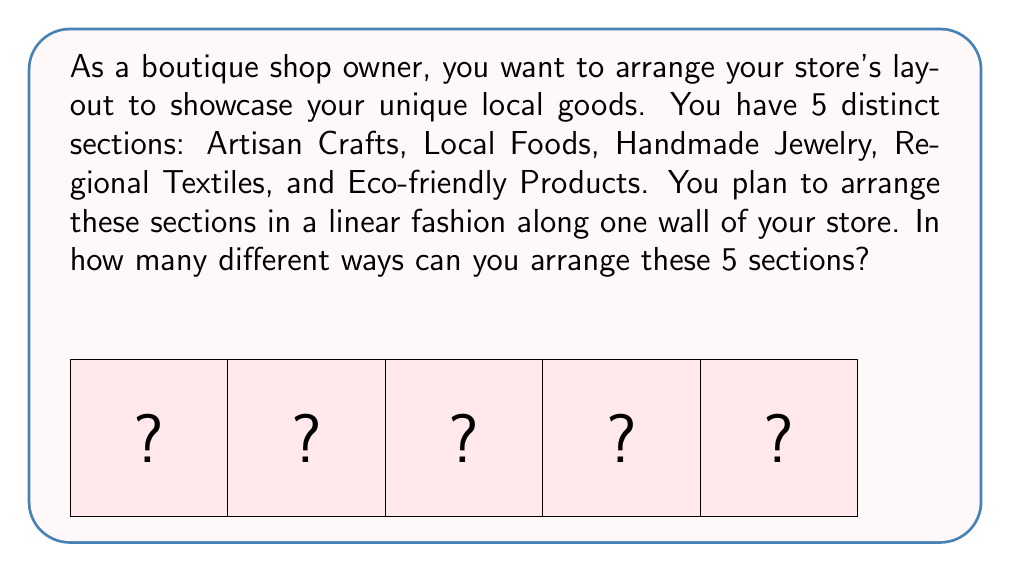What is the answer to this math problem? This problem is a classic example of a permutation. We need to determine the number of ways to arrange 5 distinct objects (the store sections) in a line.

The key steps to solve this problem are:

1) Recognize that this is a permutation problem, as the order matters (different arrangements of the sections create different layouts).

2) Recall the formula for permutations of n distinct objects:

   $$P(n) = n!$$

   where $n!$ represents the factorial of $n$.

3) In this case, $n = 5$ (as there are 5 sections to arrange).

4) Calculate $5!$:
   
   $$5! = 5 \times 4 \times 3 \times 2 \times 1 = 120$$

Therefore, there are 120 different ways to arrange the 5 sections in your boutique shop.
Answer: $120$ 